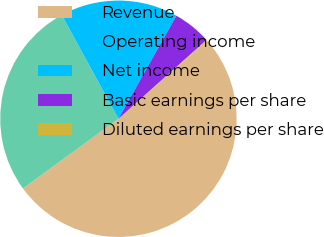<chart> <loc_0><loc_0><loc_500><loc_500><pie_chart><fcel>Revenue<fcel>Operating income<fcel>Net income<fcel>Basic earnings per share<fcel>Diluted earnings per share<nl><fcel>51.45%<fcel>27.09%<fcel>16.11%<fcel>5.24%<fcel>0.11%<nl></chart> 